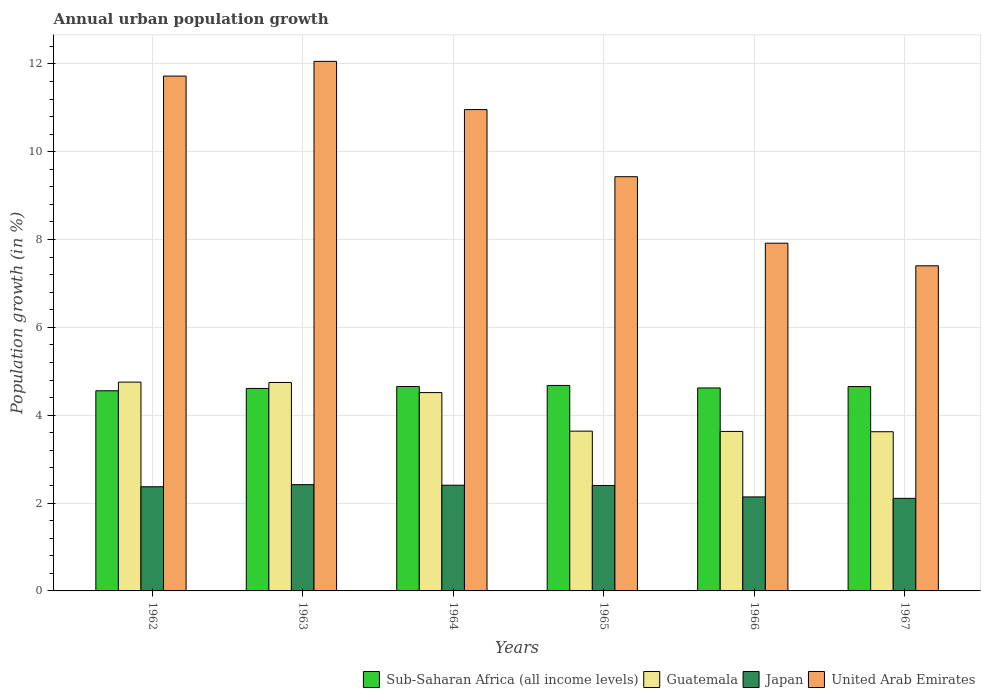How many different coloured bars are there?
Your answer should be very brief. 4. Are the number of bars per tick equal to the number of legend labels?
Offer a terse response. Yes. Are the number of bars on each tick of the X-axis equal?
Your answer should be compact. Yes. How many bars are there on the 2nd tick from the right?
Keep it short and to the point. 4. What is the label of the 3rd group of bars from the left?
Keep it short and to the point. 1964. In how many cases, is the number of bars for a given year not equal to the number of legend labels?
Offer a very short reply. 0. What is the percentage of urban population growth in Guatemala in 1965?
Give a very brief answer. 3.64. Across all years, what is the maximum percentage of urban population growth in Guatemala?
Your response must be concise. 4.75. Across all years, what is the minimum percentage of urban population growth in United Arab Emirates?
Keep it short and to the point. 7.4. In which year was the percentage of urban population growth in Guatemala maximum?
Give a very brief answer. 1962. In which year was the percentage of urban population growth in Japan minimum?
Your answer should be compact. 1967. What is the total percentage of urban population growth in Japan in the graph?
Make the answer very short. 13.85. What is the difference between the percentage of urban population growth in Guatemala in 1965 and that in 1967?
Make the answer very short. 0.01. What is the difference between the percentage of urban population growth in United Arab Emirates in 1965 and the percentage of urban population growth in Sub-Saharan Africa (all income levels) in 1967?
Give a very brief answer. 4.78. What is the average percentage of urban population growth in Guatemala per year?
Your answer should be very brief. 4.15. In the year 1967, what is the difference between the percentage of urban population growth in Japan and percentage of urban population growth in Sub-Saharan Africa (all income levels)?
Offer a terse response. -2.55. What is the ratio of the percentage of urban population growth in United Arab Emirates in 1964 to that in 1966?
Give a very brief answer. 1.38. What is the difference between the highest and the second highest percentage of urban population growth in United Arab Emirates?
Your answer should be very brief. 0.34. What is the difference between the highest and the lowest percentage of urban population growth in Sub-Saharan Africa (all income levels)?
Your answer should be compact. 0.12. Is the sum of the percentage of urban population growth in Japan in 1964 and 1966 greater than the maximum percentage of urban population growth in Guatemala across all years?
Ensure brevity in your answer.  No. Is it the case that in every year, the sum of the percentage of urban population growth in Japan and percentage of urban population growth in United Arab Emirates is greater than the sum of percentage of urban population growth in Sub-Saharan Africa (all income levels) and percentage of urban population growth in Guatemala?
Keep it short and to the point. Yes. What does the 4th bar from the right in 1966 represents?
Make the answer very short. Sub-Saharan Africa (all income levels). Is it the case that in every year, the sum of the percentage of urban population growth in Japan and percentage of urban population growth in Sub-Saharan Africa (all income levels) is greater than the percentage of urban population growth in Guatemala?
Your answer should be very brief. Yes. Are all the bars in the graph horizontal?
Provide a succinct answer. No. How many years are there in the graph?
Your answer should be very brief. 6. Does the graph contain any zero values?
Ensure brevity in your answer.  No. How many legend labels are there?
Ensure brevity in your answer.  4. What is the title of the graph?
Offer a terse response. Annual urban population growth. Does "Kuwait" appear as one of the legend labels in the graph?
Your response must be concise. No. What is the label or title of the X-axis?
Your response must be concise. Years. What is the label or title of the Y-axis?
Your response must be concise. Population growth (in %). What is the Population growth (in %) in Sub-Saharan Africa (all income levels) in 1962?
Offer a terse response. 4.56. What is the Population growth (in %) of Guatemala in 1962?
Your answer should be very brief. 4.75. What is the Population growth (in %) of Japan in 1962?
Provide a succinct answer. 2.37. What is the Population growth (in %) in United Arab Emirates in 1962?
Give a very brief answer. 11.72. What is the Population growth (in %) in Sub-Saharan Africa (all income levels) in 1963?
Offer a very short reply. 4.61. What is the Population growth (in %) in Guatemala in 1963?
Provide a short and direct response. 4.75. What is the Population growth (in %) in Japan in 1963?
Offer a very short reply. 2.42. What is the Population growth (in %) in United Arab Emirates in 1963?
Ensure brevity in your answer.  12.06. What is the Population growth (in %) of Sub-Saharan Africa (all income levels) in 1964?
Make the answer very short. 4.65. What is the Population growth (in %) of Guatemala in 1964?
Your response must be concise. 4.52. What is the Population growth (in %) of Japan in 1964?
Provide a short and direct response. 2.41. What is the Population growth (in %) of United Arab Emirates in 1964?
Offer a very short reply. 10.96. What is the Population growth (in %) of Sub-Saharan Africa (all income levels) in 1965?
Ensure brevity in your answer.  4.68. What is the Population growth (in %) in Guatemala in 1965?
Make the answer very short. 3.64. What is the Population growth (in %) in Japan in 1965?
Give a very brief answer. 2.4. What is the Population growth (in %) of United Arab Emirates in 1965?
Keep it short and to the point. 9.43. What is the Population growth (in %) in Sub-Saharan Africa (all income levels) in 1966?
Provide a short and direct response. 4.62. What is the Population growth (in %) of Guatemala in 1966?
Give a very brief answer. 3.63. What is the Population growth (in %) of Japan in 1966?
Your answer should be compact. 2.14. What is the Population growth (in %) of United Arab Emirates in 1966?
Offer a very short reply. 7.92. What is the Population growth (in %) of Sub-Saharan Africa (all income levels) in 1967?
Provide a succinct answer. 4.65. What is the Population growth (in %) in Guatemala in 1967?
Make the answer very short. 3.62. What is the Population growth (in %) of Japan in 1967?
Keep it short and to the point. 2.11. What is the Population growth (in %) in United Arab Emirates in 1967?
Ensure brevity in your answer.  7.4. Across all years, what is the maximum Population growth (in %) in Sub-Saharan Africa (all income levels)?
Your response must be concise. 4.68. Across all years, what is the maximum Population growth (in %) in Guatemala?
Offer a terse response. 4.75. Across all years, what is the maximum Population growth (in %) in Japan?
Offer a terse response. 2.42. Across all years, what is the maximum Population growth (in %) of United Arab Emirates?
Give a very brief answer. 12.06. Across all years, what is the minimum Population growth (in %) of Sub-Saharan Africa (all income levels)?
Make the answer very short. 4.56. Across all years, what is the minimum Population growth (in %) of Guatemala?
Provide a succinct answer. 3.62. Across all years, what is the minimum Population growth (in %) in Japan?
Ensure brevity in your answer.  2.11. Across all years, what is the minimum Population growth (in %) of United Arab Emirates?
Your answer should be compact. 7.4. What is the total Population growth (in %) of Sub-Saharan Africa (all income levels) in the graph?
Ensure brevity in your answer.  27.77. What is the total Population growth (in %) in Guatemala in the graph?
Offer a very short reply. 24.91. What is the total Population growth (in %) of Japan in the graph?
Give a very brief answer. 13.85. What is the total Population growth (in %) in United Arab Emirates in the graph?
Your answer should be very brief. 59.49. What is the difference between the Population growth (in %) in Sub-Saharan Africa (all income levels) in 1962 and that in 1963?
Your answer should be compact. -0.05. What is the difference between the Population growth (in %) in Guatemala in 1962 and that in 1963?
Your answer should be very brief. 0.01. What is the difference between the Population growth (in %) in Japan in 1962 and that in 1963?
Offer a terse response. -0.05. What is the difference between the Population growth (in %) in United Arab Emirates in 1962 and that in 1963?
Offer a terse response. -0.34. What is the difference between the Population growth (in %) of Sub-Saharan Africa (all income levels) in 1962 and that in 1964?
Provide a succinct answer. -0.1. What is the difference between the Population growth (in %) of Guatemala in 1962 and that in 1964?
Provide a succinct answer. 0.24. What is the difference between the Population growth (in %) of Japan in 1962 and that in 1964?
Ensure brevity in your answer.  -0.04. What is the difference between the Population growth (in %) in United Arab Emirates in 1962 and that in 1964?
Your response must be concise. 0.76. What is the difference between the Population growth (in %) of Sub-Saharan Africa (all income levels) in 1962 and that in 1965?
Ensure brevity in your answer.  -0.12. What is the difference between the Population growth (in %) of Guatemala in 1962 and that in 1965?
Give a very brief answer. 1.12. What is the difference between the Population growth (in %) in Japan in 1962 and that in 1965?
Ensure brevity in your answer.  -0.03. What is the difference between the Population growth (in %) in United Arab Emirates in 1962 and that in 1965?
Give a very brief answer. 2.29. What is the difference between the Population growth (in %) in Sub-Saharan Africa (all income levels) in 1962 and that in 1966?
Ensure brevity in your answer.  -0.06. What is the difference between the Population growth (in %) of Guatemala in 1962 and that in 1966?
Your answer should be compact. 1.12. What is the difference between the Population growth (in %) of Japan in 1962 and that in 1966?
Offer a terse response. 0.23. What is the difference between the Population growth (in %) of United Arab Emirates in 1962 and that in 1966?
Keep it short and to the point. 3.8. What is the difference between the Population growth (in %) in Sub-Saharan Africa (all income levels) in 1962 and that in 1967?
Make the answer very short. -0.1. What is the difference between the Population growth (in %) of Guatemala in 1962 and that in 1967?
Provide a short and direct response. 1.13. What is the difference between the Population growth (in %) of Japan in 1962 and that in 1967?
Offer a terse response. 0.26. What is the difference between the Population growth (in %) in United Arab Emirates in 1962 and that in 1967?
Your response must be concise. 4.32. What is the difference between the Population growth (in %) in Sub-Saharan Africa (all income levels) in 1963 and that in 1964?
Provide a succinct answer. -0.04. What is the difference between the Population growth (in %) of Guatemala in 1963 and that in 1964?
Ensure brevity in your answer.  0.23. What is the difference between the Population growth (in %) in Japan in 1963 and that in 1964?
Offer a terse response. 0.01. What is the difference between the Population growth (in %) in United Arab Emirates in 1963 and that in 1964?
Offer a terse response. 1.1. What is the difference between the Population growth (in %) in Sub-Saharan Africa (all income levels) in 1963 and that in 1965?
Your answer should be compact. -0.07. What is the difference between the Population growth (in %) of Guatemala in 1963 and that in 1965?
Your answer should be very brief. 1.11. What is the difference between the Population growth (in %) in Japan in 1963 and that in 1965?
Ensure brevity in your answer.  0.02. What is the difference between the Population growth (in %) in United Arab Emirates in 1963 and that in 1965?
Offer a terse response. 2.63. What is the difference between the Population growth (in %) in Sub-Saharan Africa (all income levels) in 1963 and that in 1966?
Your response must be concise. -0.01. What is the difference between the Population growth (in %) of Guatemala in 1963 and that in 1966?
Offer a very short reply. 1.11. What is the difference between the Population growth (in %) in Japan in 1963 and that in 1966?
Your answer should be very brief. 0.28. What is the difference between the Population growth (in %) of United Arab Emirates in 1963 and that in 1966?
Your response must be concise. 4.14. What is the difference between the Population growth (in %) in Sub-Saharan Africa (all income levels) in 1963 and that in 1967?
Offer a terse response. -0.04. What is the difference between the Population growth (in %) of Guatemala in 1963 and that in 1967?
Your answer should be very brief. 1.12. What is the difference between the Population growth (in %) in Japan in 1963 and that in 1967?
Offer a terse response. 0.31. What is the difference between the Population growth (in %) in United Arab Emirates in 1963 and that in 1967?
Provide a succinct answer. 4.66. What is the difference between the Population growth (in %) in Sub-Saharan Africa (all income levels) in 1964 and that in 1965?
Ensure brevity in your answer.  -0.02. What is the difference between the Population growth (in %) of Guatemala in 1964 and that in 1965?
Your answer should be compact. 0.88. What is the difference between the Population growth (in %) of Japan in 1964 and that in 1965?
Your response must be concise. 0.01. What is the difference between the Population growth (in %) of United Arab Emirates in 1964 and that in 1965?
Make the answer very short. 1.53. What is the difference between the Population growth (in %) of Sub-Saharan Africa (all income levels) in 1964 and that in 1966?
Provide a short and direct response. 0.03. What is the difference between the Population growth (in %) in Guatemala in 1964 and that in 1966?
Your answer should be very brief. 0.88. What is the difference between the Population growth (in %) in Japan in 1964 and that in 1966?
Offer a very short reply. 0.27. What is the difference between the Population growth (in %) of United Arab Emirates in 1964 and that in 1966?
Make the answer very short. 3.04. What is the difference between the Population growth (in %) of Sub-Saharan Africa (all income levels) in 1964 and that in 1967?
Keep it short and to the point. 0. What is the difference between the Population growth (in %) in Guatemala in 1964 and that in 1967?
Provide a short and direct response. 0.89. What is the difference between the Population growth (in %) of Japan in 1964 and that in 1967?
Give a very brief answer. 0.3. What is the difference between the Population growth (in %) in United Arab Emirates in 1964 and that in 1967?
Ensure brevity in your answer.  3.56. What is the difference between the Population growth (in %) in Sub-Saharan Africa (all income levels) in 1965 and that in 1966?
Provide a succinct answer. 0.06. What is the difference between the Population growth (in %) in Guatemala in 1965 and that in 1966?
Keep it short and to the point. 0.01. What is the difference between the Population growth (in %) in Japan in 1965 and that in 1966?
Your answer should be very brief. 0.26. What is the difference between the Population growth (in %) in United Arab Emirates in 1965 and that in 1966?
Provide a succinct answer. 1.51. What is the difference between the Population growth (in %) in Sub-Saharan Africa (all income levels) in 1965 and that in 1967?
Your response must be concise. 0.03. What is the difference between the Population growth (in %) in Guatemala in 1965 and that in 1967?
Offer a very short reply. 0.01. What is the difference between the Population growth (in %) of Japan in 1965 and that in 1967?
Provide a short and direct response. 0.29. What is the difference between the Population growth (in %) in United Arab Emirates in 1965 and that in 1967?
Keep it short and to the point. 2.03. What is the difference between the Population growth (in %) in Sub-Saharan Africa (all income levels) in 1966 and that in 1967?
Your response must be concise. -0.03. What is the difference between the Population growth (in %) in Guatemala in 1966 and that in 1967?
Your response must be concise. 0.01. What is the difference between the Population growth (in %) of Japan in 1966 and that in 1967?
Your answer should be very brief. 0.03. What is the difference between the Population growth (in %) of United Arab Emirates in 1966 and that in 1967?
Provide a short and direct response. 0.52. What is the difference between the Population growth (in %) in Sub-Saharan Africa (all income levels) in 1962 and the Population growth (in %) in Guatemala in 1963?
Your answer should be compact. -0.19. What is the difference between the Population growth (in %) of Sub-Saharan Africa (all income levels) in 1962 and the Population growth (in %) of Japan in 1963?
Offer a terse response. 2.14. What is the difference between the Population growth (in %) of Sub-Saharan Africa (all income levels) in 1962 and the Population growth (in %) of United Arab Emirates in 1963?
Make the answer very short. -7.5. What is the difference between the Population growth (in %) in Guatemala in 1962 and the Population growth (in %) in Japan in 1963?
Your response must be concise. 2.33. What is the difference between the Population growth (in %) in Guatemala in 1962 and the Population growth (in %) in United Arab Emirates in 1963?
Your answer should be very brief. -7.3. What is the difference between the Population growth (in %) of Japan in 1962 and the Population growth (in %) of United Arab Emirates in 1963?
Offer a terse response. -9.69. What is the difference between the Population growth (in %) in Sub-Saharan Africa (all income levels) in 1962 and the Population growth (in %) in Guatemala in 1964?
Provide a succinct answer. 0.04. What is the difference between the Population growth (in %) in Sub-Saharan Africa (all income levels) in 1962 and the Population growth (in %) in Japan in 1964?
Make the answer very short. 2.15. What is the difference between the Population growth (in %) of Sub-Saharan Africa (all income levels) in 1962 and the Population growth (in %) of United Arab Emirates in 1964?
Provide a succinct answer. -6.4. What is the difference between the Population growth (in %) of Guatemala in 1962 and the Population growth (in %) of Japan in 1964?
Your response must be concise. 2.35. What is the difference between the Population growth (in %) in Guatemala in 1962 and the Population growth (in %) in United Arab Emirates in 1964?
Your response must be concise. -6.21. What is the difference between the Population growth (in %) in Japan in 1962 and the Population growth (in %) in United Arab Emirates in 1964?
Provide a succinct answer. -8.59. What is the difference between the Population growth (in %) in Sub-Saharan Africa (all income levels) in 1962 and the Population growth (in %) in Guatemala in 1965?
Make the answer very short. 0.92. What is the difference between the Population growth (in %) of Sub-Saharan Africa (all income levels) in 1962 and the Population growth (in %) of Japan in 1965?
Your answer should be compact. 2.16. What is the difference between the Population growth (in %) of Sub-Saharan Africa (all income levels) in 1962 and the Population growth (in %) of United Arab Emirates in 1965?
Provide a succinct answer. -4.87. What is the difference between the Population growth (in %) in Guatemala in 1962 and the Population growth (in %) in Japan in 1965?
Offer a very short reply. 2.35. What is the difference between the Population growth (in %) in Guatemala in 1962 and the Population growth (in %) in United Arab Emirates in 1965?
Your answer should be compact. -4.68. What is the difference between the Population growth (in %) in Japan in 1962 and the Population growth (in %) in United Arab Emirates in 1965?
Ensure brevity in your answer.  -7.06. What is the difference between the Population growth (in %) in Sub-Saharan Africa (all income levels) in 1962 and the Population growth (in %) in Guatemala in 1966?
Offer a terse response. 0.93. What is the difference between the Population growth (in %) in Sub-Saharan Africa (all income levels) in 1962 and the Population growth (in %) in Japan in 1966?
Ensure brevity in your answer.  2.42. What is the difference between the Population growth (in %) of Sub-Saharan Africa (all income levels) in 1962 and the Population growth (in %) of United Arab Emirates in 1966?
Provide a short and direct response. -3.36. What is the difference between the Population growth (in %) in Guatemala in 1962 and the Population growth (in %) in Japan in 1966?
Provide a succinct answer. 2.61. What is the difference between the Population growth (in %) of Guatemala in 1962 and the Population growth (in %) of United Arab Emirates in 1966?
Give a very brief answer. -3.16. What is the difference between the Population growth (in %) of Japan in 1962 and the Population growth (in %) of United Arab Emirates in 1966?
Offer a terse response. -5.55. What is the difference between the Population growth (in %) in Sub-Saharan Africa (all income levels) in 1962 and the Population growth (in %) in Guatemala in 1967?
Offer a terse response. 0.93. What is the difference between the Population growth (in %) of Sub-Saharan Africa (all income levels) in 1962 and the Population growth (in %) of Japan in 1967?
Provide a short and direct response. 2.45. What is the difference between the Population growth (in %) in Sub-Saharan Africa (all income levels) in 1962 and the Population growth (in %) in United Arab Emirates in 1967?
Give a very brief answer. -2.85. What is the difference between the Population growth (in %) in Guatemala in 1962 and the Population growth (in %) in Japan in 1967?
Make the answer very short. 2.65. What is the difference between the Population growth (in %) in Guatemala in 1962 and the Population growth (in %) in United Arab Emirates in 1967?
Keep it short and to the point. -2.65. What is the difference between the Population growth (in %) of Japan in 1962 and the Population growth (in %) of United Arab Emirates in 1967?
Provide a short and direct response. -5.03. What is the difference between the Population growth (in %) of Sub-Saharan Africa (all income levels) in 1963 and the Population growth (in %) of Guatemala in 1964?
Provide a succinct answer. 0.09. What is the difference between the Population growth (in %) of Sub-Saharan Africa (all income levels) in 1963 and the Population growth (in %) of Japan in 1964?
Provide a succinct answer. 2.2. What is the difference between the Population growth (in %) of Sub-Saharan Africa (all income levels) in 1963 and the Population growth (in %) of United Arab Emirates in 1964?
Your response must be concise. -6.35. What is the difference between the Population growth (in %) of Guatemala in 1963 and the Population growth (in %) of Japan in 1964?
Offer a terse response. 2.34. What is the difference between the Population growth (in %) of Guatemala in 1963 and the Population growth (in %) of United Arab Emirates in 1964?
Provide a short and direct response. -6.21. What is the difference between the Population growth (in %) in Japan in 1963 and the Population growth (in %) in United Arab Emirates in 1964?
Your answer should be very brief. -8.54. What is the difference between the Population growth (in %) in Sub-Saharan Africa (all income levels) in 1963 and the Population growth (in %) in Guatemala in 1965?
Provide a short and direct response. 0.97. What is the difference between the Population growth (in %) of Sub-Saharan Africa (all income levels) in 1963 and the Population growth (in %) of Japan in 1965?
Provide a succinct answer. 2.21. What is the difference between the Population growth (in %) in Sub-Saharan Africa (all income levels) in 1963 and the Population growth (in %) in United Arab Emirates in 1965?
Make the answer very short. -4.82. What is the difference between the Population growth (in %) in Guatemala in 1963 and the Population growth (in %) in Japan in 1965?
Make the answer very short. 2.35. What is the difference between the Population growth (in %) of Guatemala in 1963 and the Population growth (in %) of United Arab Emirates in 1965?
Your response must be concise. -4.69. What is the difference between the Population growth (in %) in Japan in 1963 and the Population growth (in %) in United Arab Emirates in 1965?
Keep it short and to the point. -7.01. What is the difference between the Population growth (in %) of Sub-Saharan Africa (all income levels) in 1963 and the Population growth (in %) of Guatemala in 1966?
Your answer should be very brief. 0.98. What is the difference between the Population growth (in %) of Sub-Saharan Africa (all income levels) in 1963 and the Population growth (in %) of Japan in 1966?
Make the answer very short. 2.47. What is the difference between the Population growth (in %) of Sub-Saharan Africa (all income levels) in 1963 and the Population growth (in %) of United Arab Emirates in 1966?
Ensure brevity in your answer.  -3.31. What is the difference between the Population growth (in %) in Guatemala in 1963 and the Population growth (in %) in Japan in 1966?
Make the answer very short. 2.61. What is the difference between the Population growth (in %) in Guatemala in 1963 and the Population growth (in %) in United Arab Emirates in 1966?
Your response must be concise. -3.17. What is the difference between the Population growth (in %) of Japan in 1963 and the Population growth (in %) of United Arab Emirates in 1966?
Your answer should be compact. -5.5. What is the difference between the Population growth (in %) in Sub-Saharan Africa (all income levels) in 1963 and the Population growth (in %) in Guatemala in 1967?
Offer a very short reply. 0.99. What is the difference between the Population growth (in %) in Sub-Saharan Africa (all income levels) in 1963 and the Population growth (in %) in Japan in 1967?
Ensure brevity in your answer.  2.5. What is the difference between the Population growth (in %) in Sub-Saharan Africa (all income levels) in 1963 and the Population growth (in %) in United Arab Emirates in 1967?
Your answer should be compact. -2.79. What is the difference between the Population growth (in %) in Guatemala in 1963 and the Population growth (in %) in Japan in 1967?
Give a very brief answer. 2.64. What is the difference between the Population growth (in %) of Guatemala in 1963 and the Population growth (in %) of United Arab Emirates in 1967?
Your answer should be compact. -2.66. What is the difference between the Population growth (in %) of Japan in 1963 and the Population growth (in %) of United Arab Emirates in 1967?
Offer a terse response. -4.98. What is the difference between the Population growth (in %) in Sub-Saharan Africa (all income levels) in 1964 and the Population growth (in %) in Guatemala in 1965?
Make the answer very short. 1.02. What is the difference between the Population growth (in %) of Sub-Saharan Africa (all income levels) in 1964 and the Population growth (in %) of Japan in 1965?
Offer a terse response. 2.25. What is the difference between the Population growth (in %) of Sub-Saharan Africa (all income levels) in 1964 and the Population growth (in %) of United Arab Emirates in 1965?
Your answer should be very brief. -4.78. What is the difference between the Population growth (in %) of Guatemala in 1964 and the Population growth (in %) of Japan in 1965?
Offer a terse response. 2.12. What is the difference between the Population growth (in %) of Guatemala in 1964 and the Population growth (in %) of United Arab Emirates in 1965?
Keep it short and to the point. -4.92. What is the difference between the Population growth (in %) in Japan in 1964 and the Population growth (in %) in United Arab Emirates in 1965?
Offer a terse response. -7.02. What is the difference between the Population growth (in %) in Sub-Saharan Africa (all income levels) in 1964 and the Population growth (in %) in Guatemala in 1966?
Your response must be concise. 1.02. What is the difference between the Population growth (in %) in Sub-Saharan Africa (all income levels) in 1964 and the Population growth (in %) in Japan in 1966?
Your answer should be very brief. 2.51. What is the difference between the Population growth (in %) of Sub-Saharan Africa (all income levels) in 1964 and the Population growth (in %) of United Arab Emirates in 1966?
Give a very brief answer. -3.26. What is the difference between the Population growth (in %) of Guatemala in 1964 and the Population growth (in %) of Japan in 1966?
Make the answer very short. 2.38. What is the difference between the Population growth (in %) of Guatemala in 1964 and the Population growth (in %) of United Arab Emirates in 1966?
Ensure brevity in your answer.  -3.4. What is the difference between the Population growth (in %) of Japan in 1964 and the Population growth (in %) of United Arab Emirates in 1966?
Provide a succinct answer. -5.51. What is the difference between the Population growth (in %) of Sub-Saharan Africa (all income levels) in 1964 and the Population growth (in %) of Guatemala in 1967?
Keep it short and to the point. 1.03. What is the difference between the Population growth (in %) in Sub-Saharan Africa (all income levels) in 1964 and the Population growth (in %) in Japan in 1967?
Provide a succinct answer. 2.55. What is the difference between the Population growth (in %) in Sub-Saharan Africa (all income levels) in 1964 and the Population growth (in %) in United Arab Emirates in 1967?
Provide a succinct answer. -2.75. What is the difference between the Population growth (in %) in Guatemala in 1964 and the Population growth (in %) in Japan in 1967?
Offer a terse response. 2.41. What is the difference between the Population growth (in %) of Guatemala in 1964 and the Population growth (in %) of United Arab Emirates in 1967?
Provide a succinct answer. -2.89. What is the difference between the Population growth (in %) of Japan in 1964 and the Population growth (in %) of United Arab Emirates in 1967?
Offer a terse response. -5. What is the difference between the Population growth (in %) in Sub-Saharan Africa (all income levels) in 1965 and the Population growth (in %) in Guatemala in 1966?
Your answer should be compact. 1.05. What is the difference between the Population growth (in %) of Sub-Saharan Africa (all income levels) in 1965 and the Population growth (in %) of Japan in 1966?
Your response must be concise. 2.54. What is the difference between the Population growth (in %) of Sub-Saharan Africa (all income levels) in 1965 and the Population growth (in %) of United Arab Emirates in 1966?
Keep it short and to the point. -3.24. What is the difference between the Population growth (in %) of Guatemala in 1965 and the Population growth (in %) of Japan in 1966?
Offer a terse response. 1.5. What is the difference between the Population growth (in %) of Guatemala in 1965 and the Population growth (in %) of United Arab Emirates in 1966?
Offer a very short reply. -4.28. What is the difference between the Population growth (in %) of Japan in 1965 and the Population growth (in %) of United Arab Emirates in 1966?
Keep it short and to the point. -5.52. What is the difference between the Population growth (in %) of Sub-Saharan Africa (all income levels) in 1965 and the Population growth (in %) of Guatemala in 1967?
Ensure brevity in your answer.  1.05. What is the difference between the Population growth (in %) in Sub-Saharan Africa (all income levels) in 1965 and the Population growth (in %) in Japan in 1967?
Provide a succinct answer. 2.57. What is the difference between the Population growth (in %) in Sub-Saharan Africa (all income levels) in 1965 and the Population growth (in %) in United Arab Emirates in 1967?
Provide a short and direct response. -2.72. What is the difference between the Population growth (in %) of Guatemala in 1965 and the Population growth (in %) of Japan in 1967?
Keep it short and to the point. 1.53. What is the difference between the Population growth (in %) in Guatemala in 1965 and the Population growth (in %) in United Arab Emirates in 1967?
Provide a succinct answer. -3.76. What is the difference between the Population growth (in %) in Japan in 1965 and the Population growth (in %) in United Arab Emirates in 1967?
Provide a succinct answer. -5. What is the difference between the Population growth (in %) of Sub-Saharan Africa (all income levels) in 1966 and the Population growth (in %) of Japan in 1967?
Your answer should be very brief. 2.51. What is the difference between the Population growth (in %) in Sub-Saharan Africa (all income levels) in 1966 and the Population growth (in %) in United Arab Emirates in 1967?
Offer a terse response. -2.78. What is the difference between the Population growth (in %) of Guatemala in 1966 and the Population growth (in %) of Japan in 1967?
Keep it short and to the point. 1.52. What is the difference between the Population growth (in %) in Guatemala in 1966 and the Population growth (in %) in United Arab Emirates in 1967?
Your response must be concise. -3.77. What is the difference between the Population growth (in %) of Japan in 1966 and the Population growth (in %) of United Arab Emirates in 1967?
Provide a succinct answer. -5.26. What is the average Population growth (in %) in Sub-Saharan Africa (all income levels) per year?
Give a very brief answer. 4.63. What is the average Population growth (in %) in Guatemala per year?
Give a very brief answer. 4.15. What is the average Population growth (in %) of Japan per year?
Provide a short and direct response. 2.31. What is the average Population growth (in %) of United Arab Emirates per year?
Your answer should be compact. 9.91. In the year 1962, what is the difference between the Population growth (in %) of Sub-Saharan Africa (all income levels) and Population growth (in %) of Guatemala?
Make the answer very short. -0.2. In the year 1962, what is the difference between the Population growth (in %) in Sub-Saharan Africa (all income levels) and Population growth (in %) in Japan?
Your answer should be very brief. 2.19. In the year 1962, what is the difference between the Population growth (in %) of Sub-Saharan Africa (all income levels) and Population growth (in %) of United Arab Emirates?
Provide a succinct answer. -7.16. In the year 1962, what is the difference between the Population growth (in %) in Guatemala and Population growth (in %) in Japan?
Offer a very short reply. 2.38. In the year 1962, what is the difference between the Population growth (in %) of Guatemala and Population growth (in %) of United Arab Emirates?
Your answer should be very brief. -6.97. In the year 1962, what is the difference between the Population growth (in %) in Japan and Population growth (in %) in United Arab Emirates?
Offer a terse response. -9.35. In the year 1963, what is the difference between the Population growth (in %) of Sub-Saharan Africa (all income levels) and Population growth (in %) of Guatemala?
Offer a very short reply. -0.14. In the year 1963, what is the difference between the Population growth (in %) of Sub-Saharan Africa (all income levels) and Population growth (in %) of Japan?
Keep it short and to the point. 2.19. In the year 1963, what is the difference between the Population growth (in %) in Sub-Saharan Africa (all income levels) and Population growth (in %) in United Arab Emirates?
Ensure brevity in your answer.  -7.45. In the year 1963, what is the difference between the Population growth (in %) in Guatemala and Population growth (in %) in Japan?
Provide a short and direct response. 2.33. In the year 1963, what is the difference between the Population growth (in %) of Guatemala and Population growth (in %) of United Arab Emirates?
Keep it short and to the point. -7.31. In the year 1963, what is the difference between the Population growth (in %) in Japan and Population growth (in %) in United Arab Emirates?
Provide a short and direct response. -9.64. In the year 1964, what is the difference between the Population growth (in %) in Sub-Saharan Africa (all income levels) and Population growth (in %) in Guatemala?
Provide a short and direct response. 0.14. In the year 1964, what is the difference between the Population growth (in %) in Sub-Saharan Africa (all income levels) and Population growth (in %) in Japan?
Offer a very short reply. 2.25. In the year 1964, what is the difference between the Population growth (in %) in Sub-Saharan Africa (all income levels) and Population growth (in %) in United Arab Emirates?
Ensure brevity in your answer.  -6.31. In the year 1964, what is the difference between the Population growth (in %) of Guatemala and Population growth (in %) of Japan?
Offer a terse response. 2.11. In the year 1964, what is the difference between the Population growth (in %) of Guatemala and Population growth (in %) of United Arab Emirates?
Offer a terse response. -6.44. In the year 1964, what is the difference between the Population growth (in %) of Japan and Population growth (in %) of United Arab Emirates?
Your response must be concise. -8.55. In the year 1965, what is the difference between the Population growth (in %) of Sub-Saharan Africa (all income levels) and Population growth (in %) of Guatemala?
Your answer should be very brief. 1.04. In the year 1965, what is the difference between the Population growth (in %) in Sub-Saharan Africa (all income levels) and Population growth (in %) in Japan?
Provide a short and direct response. 2.28. In the year 1965, what is the difference between the Population growth (in %) in Sub-Saharan Africa (all income levels) and Population growth (in %) in United Arab Emirates?
Offer a terse response. -4.75. In the year 1965, what is the difference between the Population growth (in %) in Guatemala and Population growth (in %) in Japan?
Keep it short and to the point. 1.24. In the year 1965, what is the difference between the Population growth (in %) of Guatemala and Population growth (in %) of United Arab Emirates?
Offer a very short reply. -5.79. In the year 1965, what is the difference between the Population growth (in %) in Japan and Population growth (in %) in United Arab Emirates?
Your response must be concise. -7.03. In the year 1966, what is the difference between the Population growth (in %) of Sub-Saharan Africa (all income levels) and Population growth (in %) of Guatemala?
Provide a succinct answer. 0.99. In the year 1966, what is the difference between the Population growth (in %) of Sub-Saharan Africa (all income levels) and Population growth (in %) of Japan?
Make the answer very short. 2.48. In the year 1966, what is the difference between the Population growth (in %) of Sub-Saharan Africa (all income levels) and Population growth (in %) of United Arab Emirates?
Your answer should be very brief. -3.3. In the year 1966, what is the difference between the Population growth (in %) of Guatemala and Population growth (in %) of Japan?
Your response must be concise. 1.49. In the year 1966, what is the difference between the Population growth (in %) in Guatemala and Population growth (in %) in United Arab Emirates?
Keep it short and to the point. -4.29. In the year 1966, what is the difference between the Population growth (in %) in Japan and Population growth (in %) in United Arab Emirates?
Offer a terse response. -5.78. In the year 1967, what is the difference between the Population growth (in %) in Sub-Saharan Africa (all income levels) and Population growth (in %) in Guatemala?
Provide a succinct answer. 1.03. In the year 1967, what is the difference between the Population growth (in %) of Sub-Saharan Africa (all income levels) and Population growth (in %) of Japan?
Offer a terse response. 2.54. In the year 1967, what is the difference between the Population growth (in %) in Sub-Saharan Africa (all income levels) and Population growth (in %) in United Arab Emirates?
Give a very brief answer. -2.75. In the year 1967, what is the difference between the Population growth (in %) in Guatemala and Population growth (in %) in Japan?
Give a very brief answer. 1.52. In the year 1967, what is the difference between the Population growth (in %) in Guatemala and Population growth (in %) in United Arab Emirates?
Make the answer very short. -3.78. In the year 1967, what is the difference between the Population growth (in %) in Japan and Population growth (in %) in United Arab Emirates?
Keep it short and to the point. -5.29. What is the ratio of the Population growth (in %) in Japan in 1962 to that in 1963?
Offer a terse response. 0.98. What is the ratio of the Population growth (in %) of United Arab Emirates in 1962 to that in 1963?
Offer a very short reply. 0.97. What is the ratio of the Population growth (in %) in Sub-Saharan Africa (all income levels) in 1962 to that in 1964?
Your answer should be very brief. 0.98. What is the ratio of the Population growth (in %) in Guatemala in 1962 to that in 1964?
Give a very brief answer. 1.05. What is the ratio of the Population growth (in %) in Japan in 1962 to that in 1964?
Give a very brief answer. 0.99. What is the ratio of the Population growth (in %) of United Arab Emirates in 1962 to that in 1964?
Make the answer very short. 1.07. What is the ratio of the Population growth (in %) of Sub-Saharan Africa (all income levels) in 1962 to that in 1965?
Offer a very short reply. 0.97. What is the ratio of the Population growth (in %) of Guatemala in 1962 to that in 1965?
Ensure brevity in your answer.  1.31. What is the ratio of the Population growth (in %) in United Arab Emirates in 1962 to that in 1965?
Provide a short and direct response. 1.24. What is the ratio of the Population growth (in %) of Sub-Saharan Africa (all income levels) in 1962 to that in 1966?
Your answer should be very brief. 0.99. What is the ratio of the Population growth (in %) of Guatemala in 1962 to that in 1966?
Provide a succinct answer. 1.31. What is the ratio of the Population growth (in %) in Japan in 1962 to that in 1966?
Provide a short and direct response. 1.11. What is the ratio of the Population growth (in %) of United Arab Emirates in 1962 to that in 1966?
Your response must be concise. 1.48. What is the ratio of the Population growth (in %) of Sub-Saharan Africa (all income levels) in 1962 to that in 1967?
Offer a very short reply. 0.98. What is the ratio of the Population growth (in %) of Guatemala in 1962 to that in 1967?
Provide a short and direct response. 1.31. What is the ratio of the Population growth (in %) of Japan in 1962 to that in 1967?
Offer a terse response. 1.13. What is the ratio of the Population growth (in %) of United Arab Emirates in 1962 to that in 1967?
Keep it short and to the point. 1.58. What is the ratio of the Population growth (in %) in Guatemala in 1963 to that in 1964?
Make the answer very short. 1.05. What is the ratio of the Population growth (in %) in Japan in 1963 to that in 1964?
Offer a very short reply. 1.01. What is the ratio of the Population growth (in %) of United Arab Emirates in 1963 to that in 1964?
Provide a short and direct response. 1.1. What is the ratio of the Population growth (in %) of Sub-Saharan Africa (all income levels) in 1963 to that in 1965?
Offer a very short reply. 0.99. What is the ratio of the Population growth (in %) of Guatemala in 1963 to that in 1965?
Provide a short and direct response. 1.3. What is the ratio of the Population growth (in %) in Japan in 1963 to that in 1965?
Provide a short and direct response. 1.01. What is the ratio of the Population growth (in %) in United Arab Emirates in 1963 to that in 1965?
Keep it short and to the point. 1.28. What is the ratio of the Population growth (in %) of Sub-Saharan Africa (all income levels) in 1963 to that in 1966?
Offer a terse response. 1. What is the ratio of the Population growth (in %) in Guatemala in 1963 to that in 1966?
Provide a short and direct response. 1.31. What is the ratio of the Population growth (in %) of Japan in 1963 to that in 1966?
Provide a short and direct response. 1.13. What is the ratio of the Population growth (in %) in United Arab Emirates in 1963 to that in 1966?
Ensure brevity in your answer.  1.52. What is the ratio of the Population growth (in %) of Sub-Saharan Africa (all income levels) in 1963 to that in 1967?
Make the answer very short. 0.99. What is the ratio of the Population growth (in %) in Guatemala in 1963 to that in 1967?
Ensure brevity in your answer.  1.31. What is the ratio of the Population growth (in %) in Japan in 1963 to that in 1967?
Keep it short and to the point. 1.15. What is the ratio of the Population growth (in %) in United Arab Emirates in 1963 to that in 1967?
Offer a terse response. 1.63. What is the ratio of the Population growth (in %) of Sub-Saharan Africa (all income levels) in 1964 to that in 1965?
Your answer should be compact. 0.99. What is the ratio of the Population growth (in %) in Guatemala in 1964 to that in 1965?
Ensure brevity in your answer.  1.24. What is the ratio of the Population growth (in %) in United Arab Emirates in 1964 to that in 1965?
Offer a terse response. 1.16. What is the ratio of the Population growth (in %) of Sub-Saharan Africa (all income levels) in 1964 to that in 1966?
Offer a terse response. 1.01. What is the ratio of the Population growth (in %) of Guatemala in 1964 to that in 1966?
Offer a terse response. 1.24. What is the ratio of the Population growth (in %) in Japan in 1964 to that in 1966?
Your answer should be compact. 1.12. What is the ratio of the Population growth (in %) of United Arab Emirates in 1964 to that in 1966?
Keep it short and to the point. 1.38. What is the ratio of the Population growth (in %) of Sub-Saharan Africa (all income levels) in 1964 to that in 1967?
Give a very brief answer. 1. What is the ratio of the Population growth (in %) of Guatemala in 1964 to that in 1967?
Keep it short and to the point. 1.25. What is the ratio of the Population growth (in %) of Japan in 1964 to that in 1967?
Ensure brevity in your answer.  1.14. What is the ratio of the Population growth (in %) in United Arab Emirates in 1964 to that in 1967?
Ensure brevity in your answer.  1.48. What is the ratio of the Population growth (in %) of Sub-Saharan Africa (all income levels) in 1965 to that in 1966?
Offer a terse response. 1.01. What is the ratio of the Population growth (in %) in Japan in 1965 to that in 1966?
Your response must be concise. 1.12. What is the ratio of the Population growth (in %) in United Arab Emirates in 1965 to that in 1966?
Give a very brief answer. 1.19. What is the ratio of the Population growth (in %) in Sub-Saharan Africa (all income levels) in 1965 to that in 1967?
Keep it short and to the point. 1.01. What is the ratio of the Population growth (in %) of Guatemala in 1965 to that in 1967?
Your answer should be very brief. 1. What is the ratio of the Population growth (in %) of Japan in 1965 to that in 1967?
Give a very brief answer. 1.14. What is the ratio of the Population growth (in %) of United Arab Emirates in 1965 to that in 1967?
Offer a very short reply. 1.27. What is the ratio of the Population growth (in %) in Sub-Saharan Africa (all income levels) in 1966 to that in 1967?
Offer a very short reply. 0.99. What is the ratio of the Population growth (in %) in Japan in 1966 to that in 1967?
Your answer should be very brief. 1.02. What is the ratio of the Population growth (in %) of United Arab Emirates in 1966 to that in 1967?
Ensure brevity in your answer.  1.07. What is the difference between the highest and the second highest Population growth (in %) of Sub-Saharan Africa (all income levels)?
Your answer should be very brief. 0.02. What is the difference between the highest and the second highest Population growth (in %) of Guatemala?
Give a very brief answer. 0.01. What is the difference between the highest and the second highest Population growth (in %) in Japan?
Your answer should be very brief. 0.01. What is the difference between the highest and the second highest Population growth (in %) in United Arab Emirates?
Offer a terse response. 0.34. What is the difference between the highest and the lowest Population growth (in %) in Sub-Saharan Africa (all income levels)?
Make the answer very short. 0.12. What is the difference between the highest and the lowest Population growth (in %) in Guatemala?
Provide a succinct answer. 1.13. What is the difference between the highest and the lowest Population growth (in %) in Japan?
Keep it short and to the point. 0.31. What is the difference between the highest and the lowest Population growth (in %) in United Arab Emirates?
Make the answer very short. 4.66. 